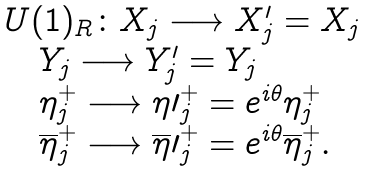<formula> <loc_0><loc_0><loc_500><loc_500>\begin{array} { l c r } { { U ( 1 ) _ { R } \colon X _ { j } \longrightarrow X _ { j } ^ { \prime } = X _ { j } } } \\ { { \quad Y _ { j } \longrightarrow Y _ { j } ^ { \prime } = Y _ { j } } } \\ { { \quad \eta _ { j } ^ { + } \longrightarrow \eta \prime _ { j } ^ { + } = e ^ { i \theta } \eta _ { j } ^ { + } } } \\ { { \quad \overline { \eta } _ { j } ^ { + } \longrightarrow \overline { \eta } \prime _ { j } ^ { + } = e ^ { i \theta } \overline { \eta } _ { j } ^ { + } . } } \end{array}</formula> 